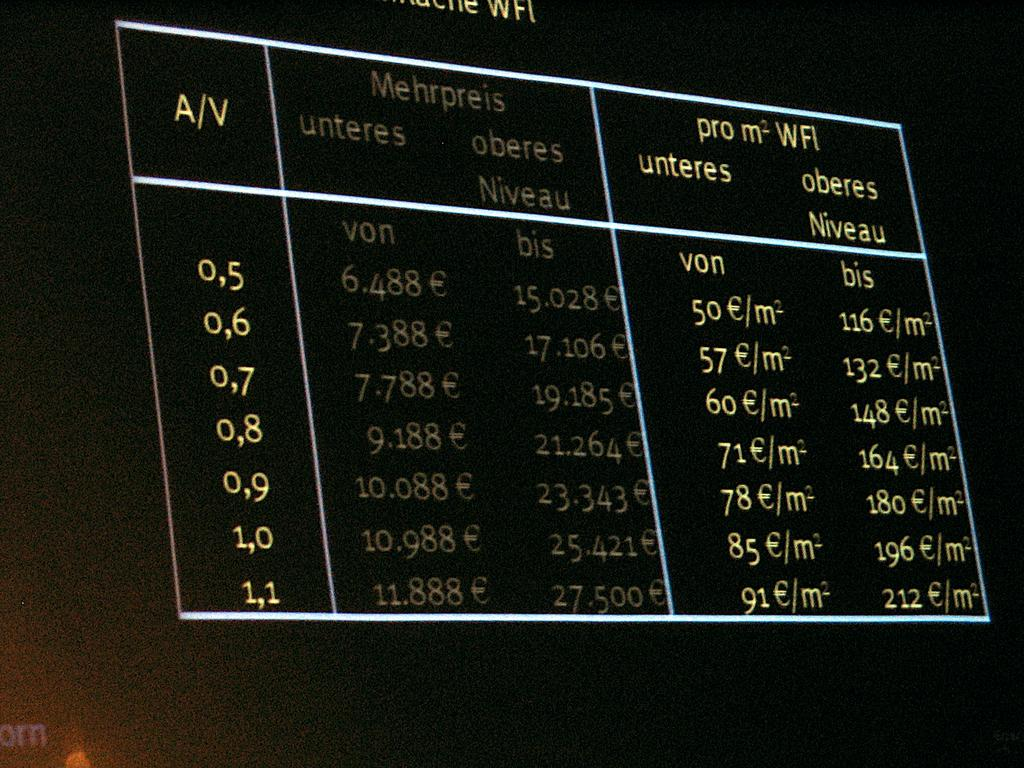What is the main object in the image that resembles a board? There is an object in the image that resembles a board. What can be seen on the board? There is text visible on the board. What type of blade can be seen cutting through the board in the image? There is no blade cutting through the board in the image; it only shows the board with text. 